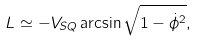<formula> <loc_0><loc_0><loc_500><loc_500>L \simeq - V _ { S Q } \arcsin \sqrt { 1 - \dot { \phi } ^ { 2 } } ,</formula> 